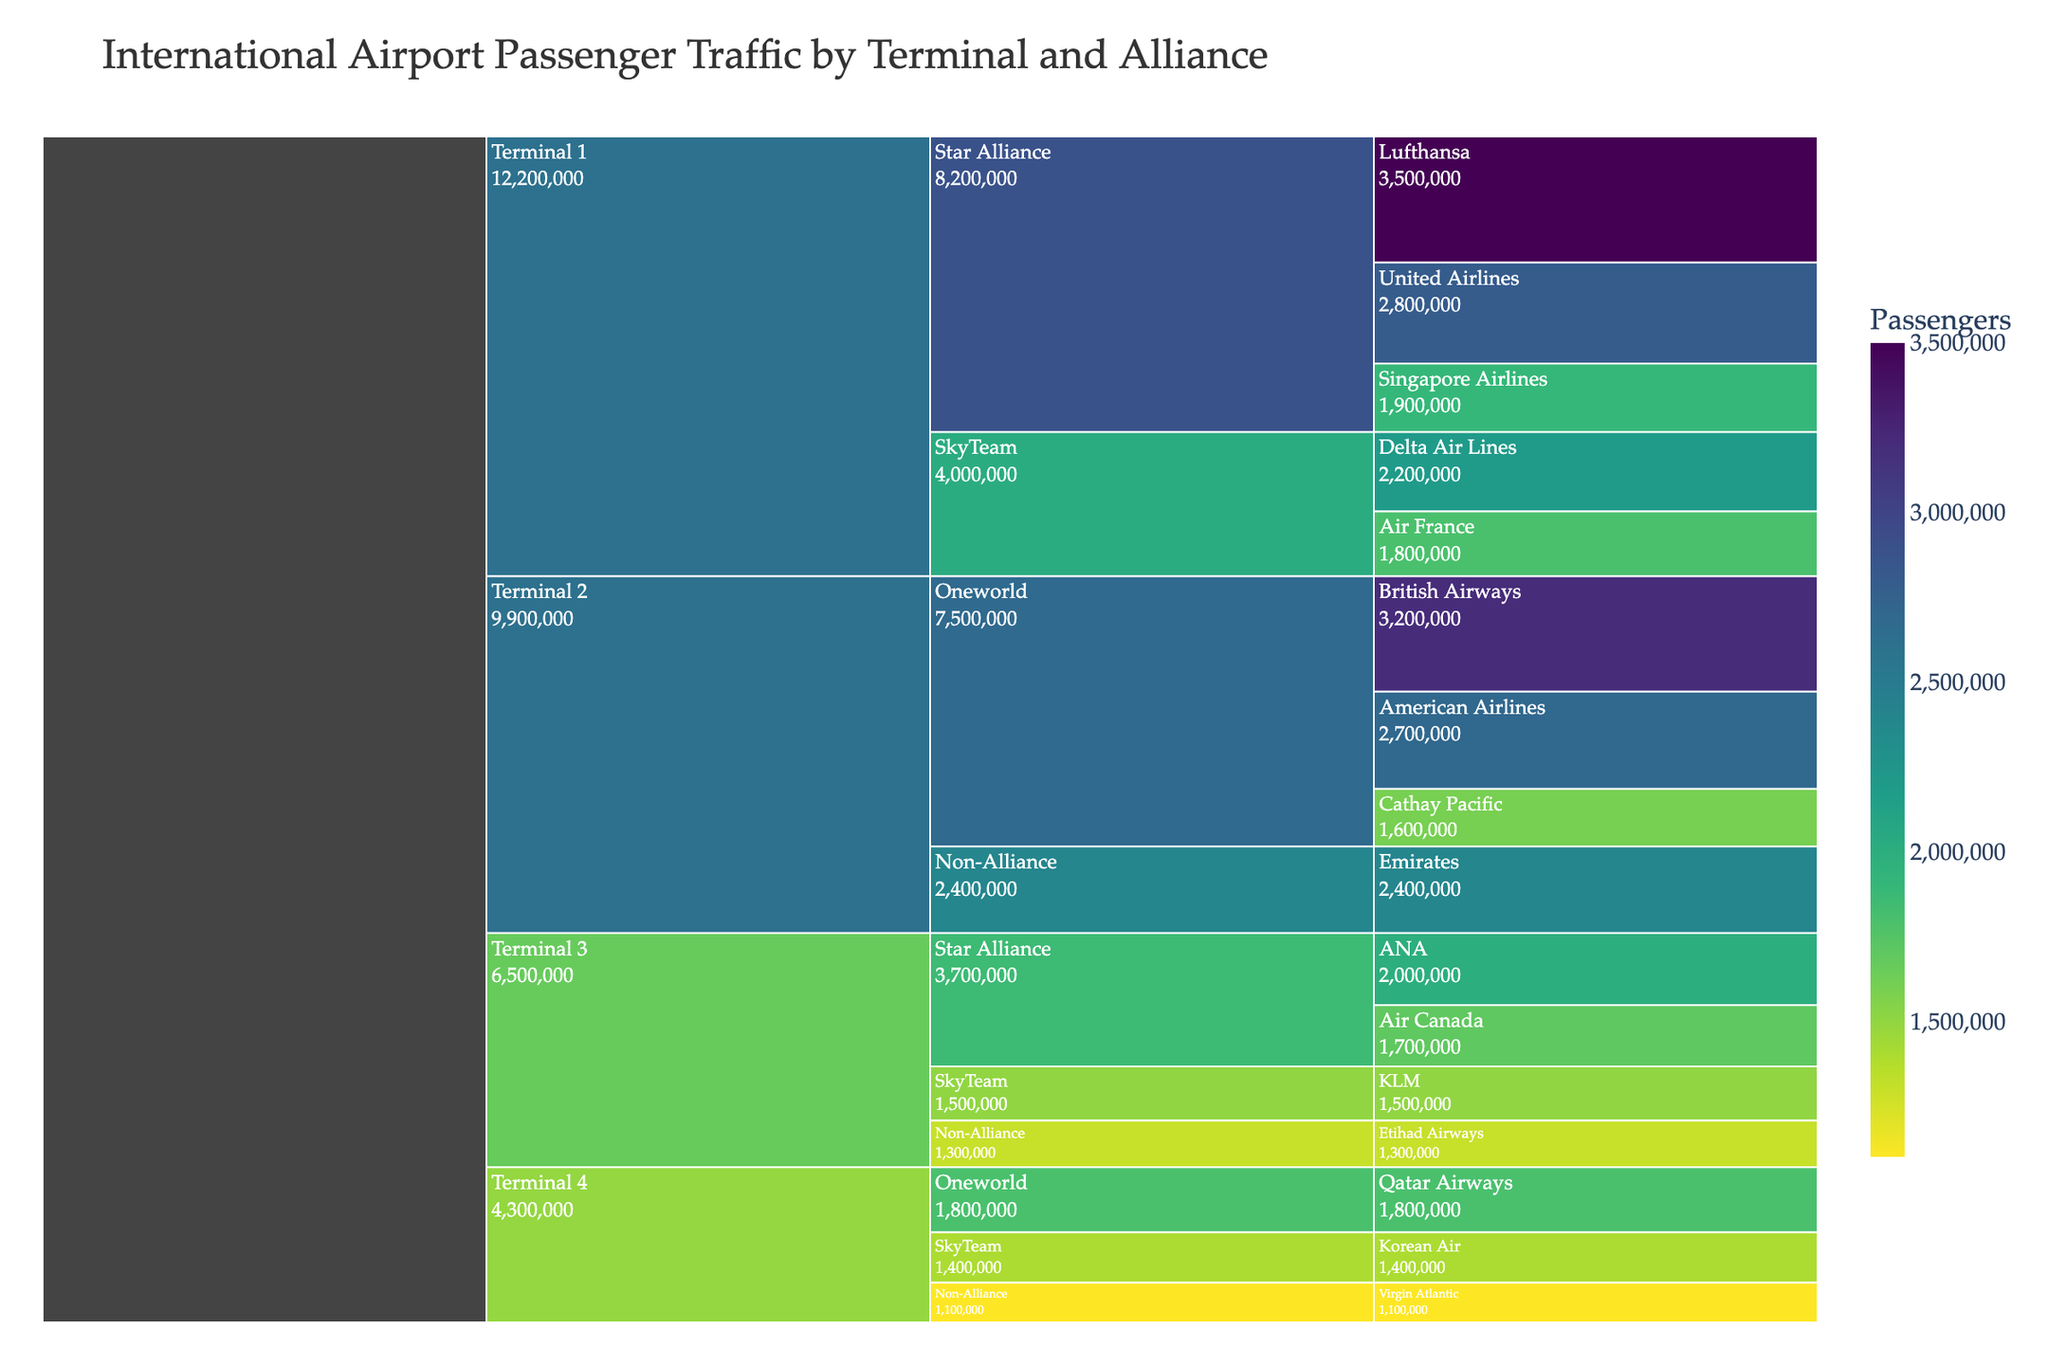what is the title of the chart? The title of the chart is displayed at the top and provides context about the data being visualized. Reading the title helps understand what the chart represents.
Answer: International Airport Passenger Traffic by Terminal and Alliance How many terminals are represented in the chart? To find the number of terminals, look at the top level of the Icicle chart. Each top-level node represents a terminal. Count these nodes.
Answer: 4 Which terminal has the highest number of passengers for Star Alliance members? Locate the nodes for Star Alliance under each terminal. Compare the sum of passengers for Star Alliance airlines in each terminal.
Answer: Terminal 1 What’s the combined number of passengers for SkyTeam in Terminal 4? Identify SkyTeam under Terminal 4 and sum up the passengers for Korean Air.
Answer: 1,400,000 What is the total number of passengers for all terminals combined? Sum the passenger numbers for all airlines in all terminals.
Answer: 27,300,000 Compare the number of passengers of Lufthansa and ANA. Which one has more passengers? Locate the data for Lufthansa and ANA. Compare the passenger values directly.
Answer: Lufthansa Which non-alliance airline in Terminal 2 has the most passengers? Among the non-alliance airlines in Terminal 2, find the airline with the highest number of passengers.
Answer: Emirates Between Terminal 1 and Terminal 3, which has the higher total passenger count for SkyTeam? Sum the passenger numbers for SkyTeam airlines under Terminal 1 and Terminal 3 separately, then compare the totals.
Answer: Terminal 1 What’s the average number of passengers for Oneworld airlines in Terminal 2? Locate the Oneworld section under Terminal 2. Sum the passengers for British Airways, American Airlines, and Cathay Pacific, then divide by 3.
Answer: 2,166,667 Among all airlines in Terminal 4, which alliance has the fewest total passengers and what is the count? Sum the passenger numbers for each alliance under Terminal 4. Compare these sums to find the alliance with the fewest passengers.
Answer: Non-Alliance, 1,100,000 